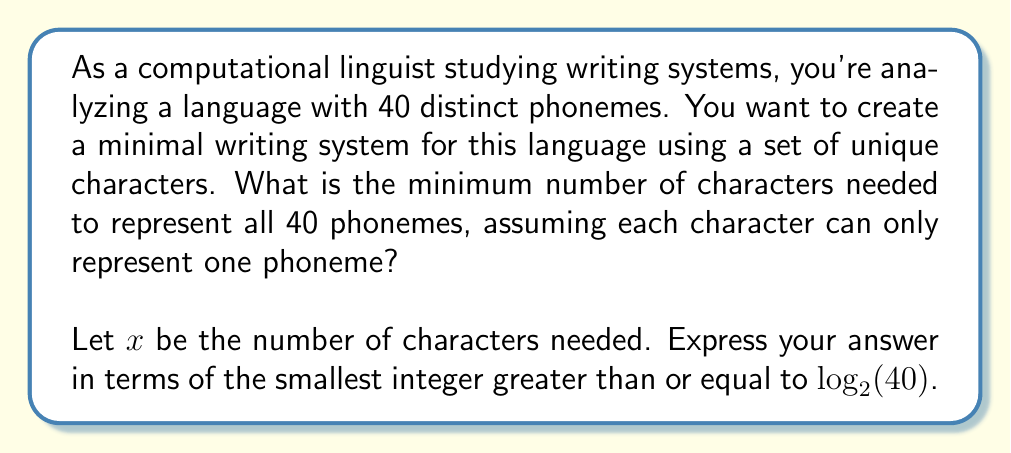What is the answer to this math problem? To solve this problem, we need to consider the relationship between the number of phonemes and the minimum number of characters required to represent them uniquely. This is essentially a problem of information theory and can be solved using the concept of binary encoding.

1) Each character in our writing system needs to uniquely represent a phoneme. Therefore, we need at least as many unique combinations of characters as there are phonemes.

2) If we have $x$ characters, we can create $2^x$ unique combinations using these characters (considering each character as either present or absent in a combination).

3) We need these combinations to be at least as many as the number of phonemes:

   $$2^x \geq 40$$

4) Taking the logarithm (base 2) of both sides:

   $$\log_2(2^x) \geq \log_2(40)$$
   $$x \geq \log_2(40)$$

5) Since $x$ must be an integer (we can't have a fractional number of characters), we need the smallest integer greater than or equal to $\log_2(40)$.

6) This is represented mathematically as the ceiling function:

   $$x = \lceil\log_2(40)\rceil$$

Therefore, the minimum number of characters needed is the smallest integer greater than or equal to $\log_2(40)$.
Answer: $\lceil\log_2(40)\rceil$ characters 